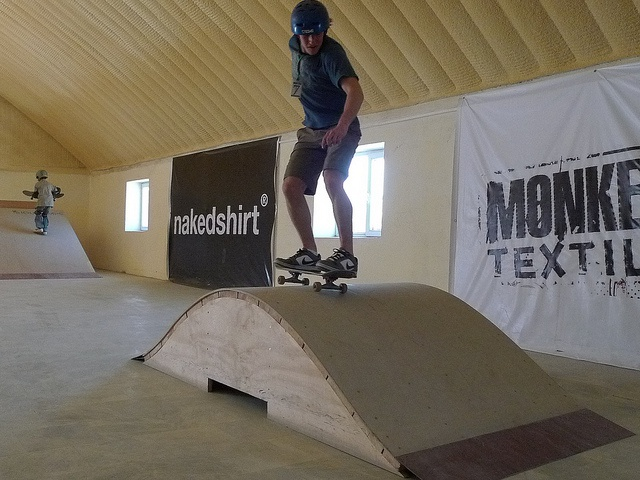Describe the objects in this image and their specific colors. I can see people in tan, black, and gray tones, people in tan, gray, and black tones, skateboard in tan, black, and gray tones, and skateboard in tan, black, and gray tones in this image. 